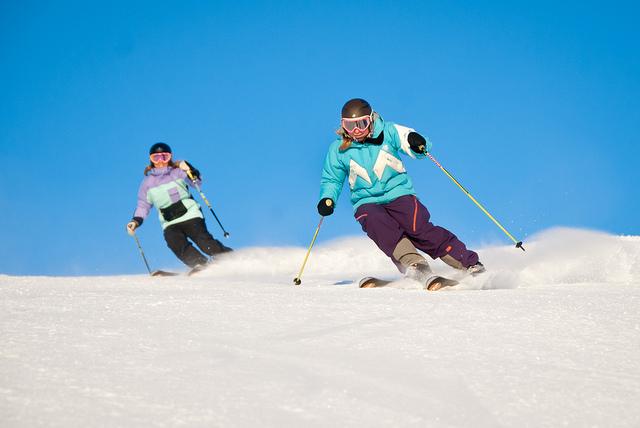Are both people skiing?
Keep it brief. Yes. Is this a slalom course?
Keep it brief. No. Why do they wear goggles?
Answer briefly. Protect eyes. 